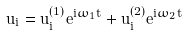<formula> <loc_0><loc_0><loc_500><loc_500>u _ { i } = u _ { i } ^ { ( 1 ) } e ^ { i \omega _ { 1 } t } + u _ { i } ^ { ( 2 ) } e ^ { i \omega _ { 2 } t } \,</formula> 